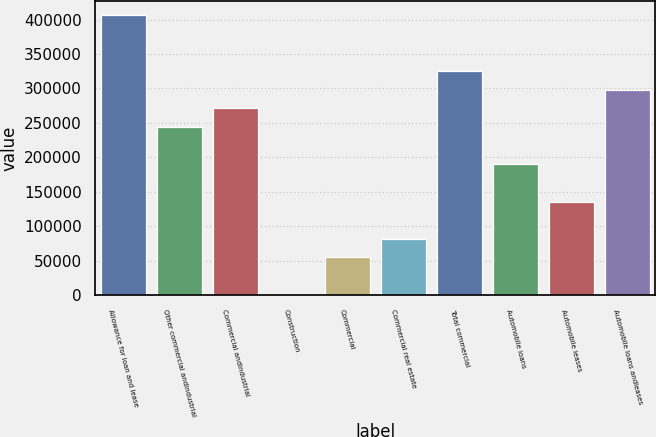<chart> <loc_0><loc_0><loc_500><loc_500><bar_chart><fcel>Allowance for loan and lease<fcel>Other commercial andindustrial<fcel>Commercial andindustrial<fcel>Construction<fcel>Commercial<fcel>Commercial real estate<fcel>Total commercial<fcel>Automobile loans<fcel>Automobile leases<fcel>Automobile loans andleases<nl><fcel>406550<fcel>244143<fcel>271211<fcel>534<fcel>54669.4<fcel>81737.1<fcel>325346<fcel>190008<fcel>135872<fcel>298279<nl></chart> 